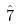<formula> <loc_0><loc_0><loc_500><loc_500>\hat { 7 }</formula> 